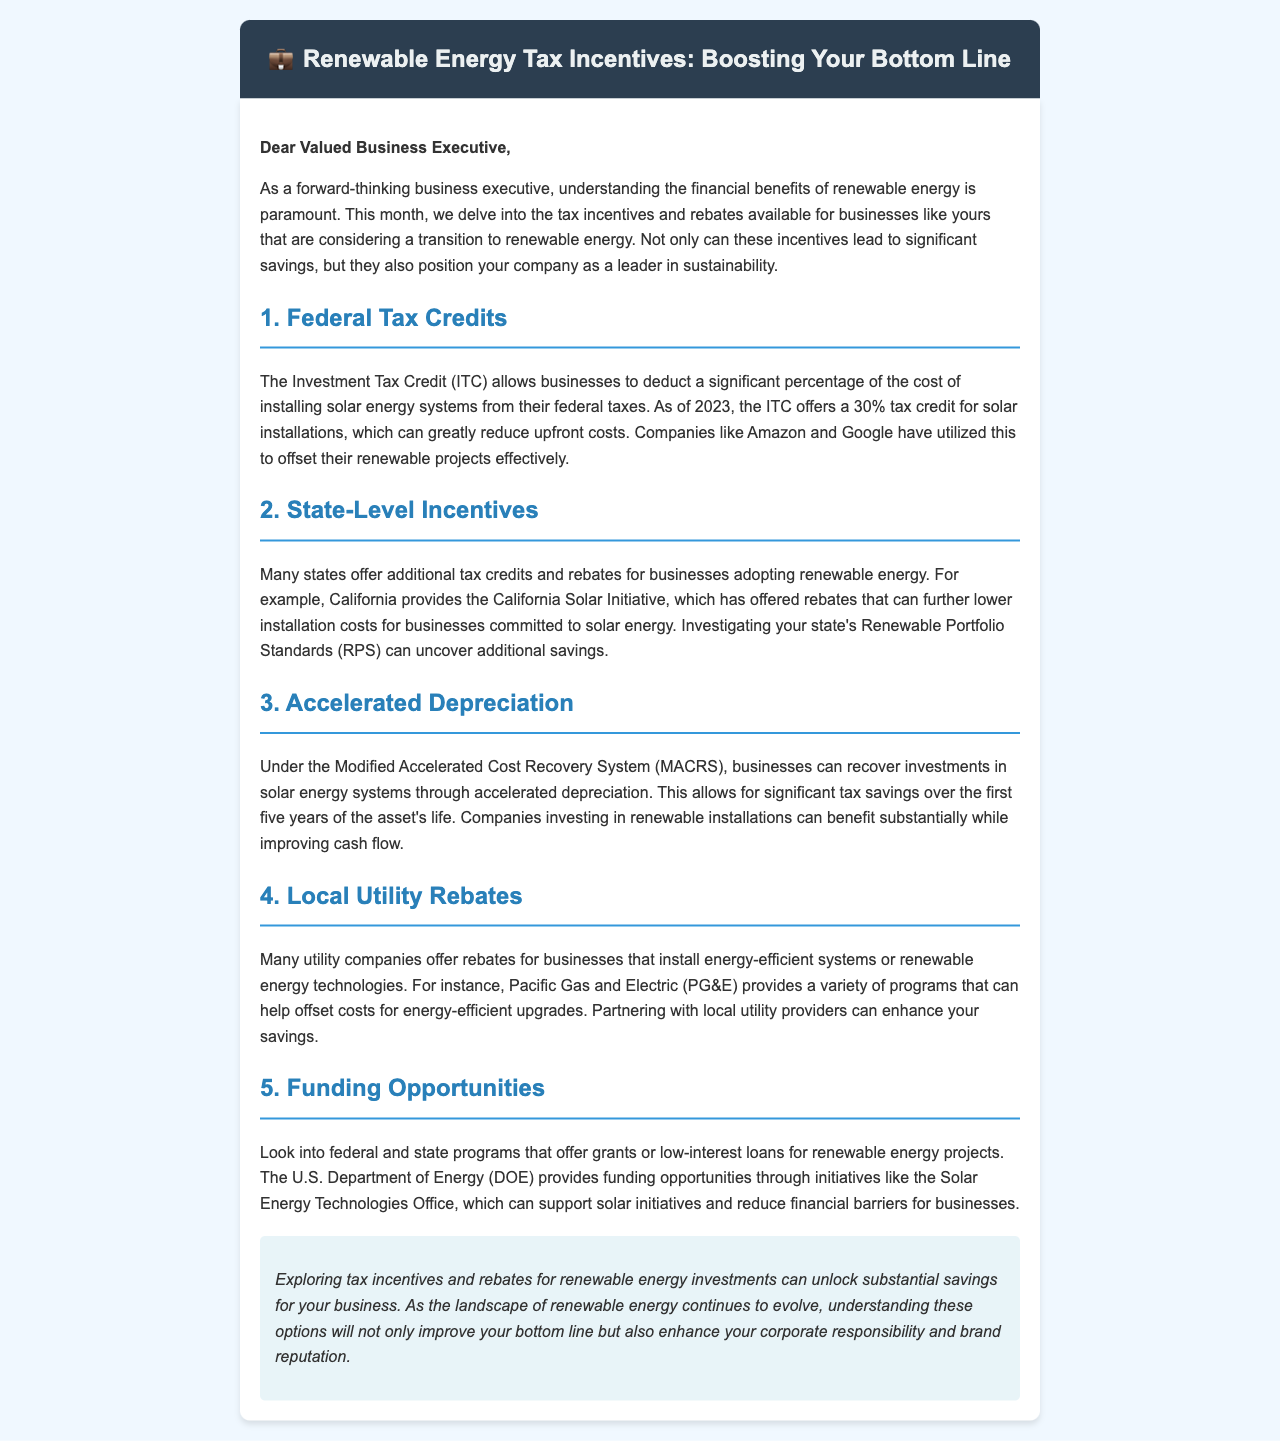What is the tax credit percentage offered by the ITC for solar installations as of 2023? The ITC offers a 30% tax credit for solar installations as of 2023.
Answer: 30% Which initiative in California provides rebates for solar energy adoption? The California Solar Initiative provides rebates for solar energy adoption.
Answer: California Solar Initiative What system allows businesses to recover investments in solar energy through accelerated depreciation? The Modified Accelerated Cost Recovery System (MACRS) allows this recovery.
Answer: MACRS Who provides funding opportunities through initiatives like the Solar Energy Technologies Office? The U.S. Department of Energy (DOE) provides funding opportunities.
Answer: U.S. Department of Energy What is one advantage of partnering with local utility providers mentioned in the document? Partnering with local utility providers can enhance savings for businesses.
Answer: Enhance savings What is the document's primary focus regarding renewable energy? The primary focus is on exploring tax incentives and rebates for renewable energy investments.
Answer: Tax incentives and rebates Which companies have utilized the ITC to offset their renewable projects? Companies like Amazon and Google have utilized the ITC effectively.
Answer: Amazon and Google What type of document is this? This document is a newsletter aimed at business executives regarding renewable energy tax incentives.
Answer: Newsletter 